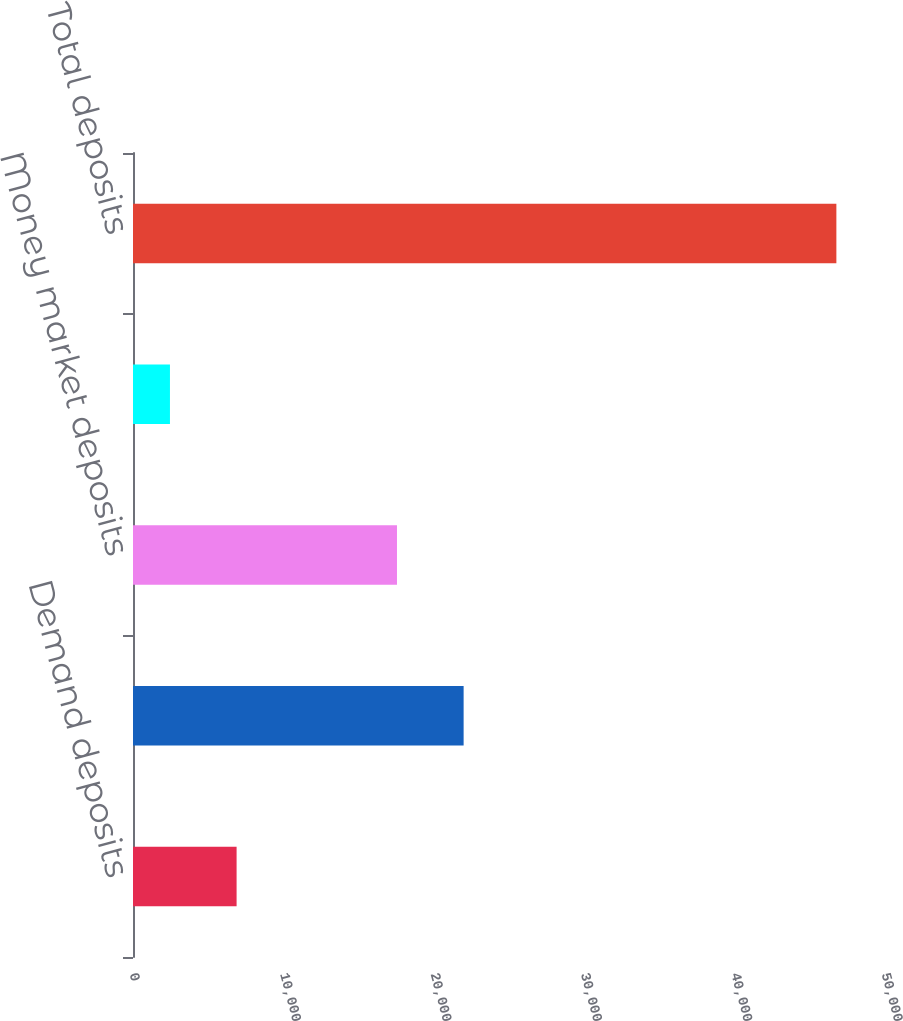Convert chart. <chart><loc_0><loc_0><loc_500><loc_500><bar_chart><fcel>Demand deposits<fcel>Total demand deposits<fcel>Money market deposits<fcel>Other deposits<fcel>Total deposits<nl><fcel>6888<fcel>21983<fcel>17552<fcel>2457<fcel>46767<nl></chart> 